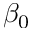<formula> <loc_0><loc_0><loc_500><loc_500>\beta _ { 0 }</formula> 